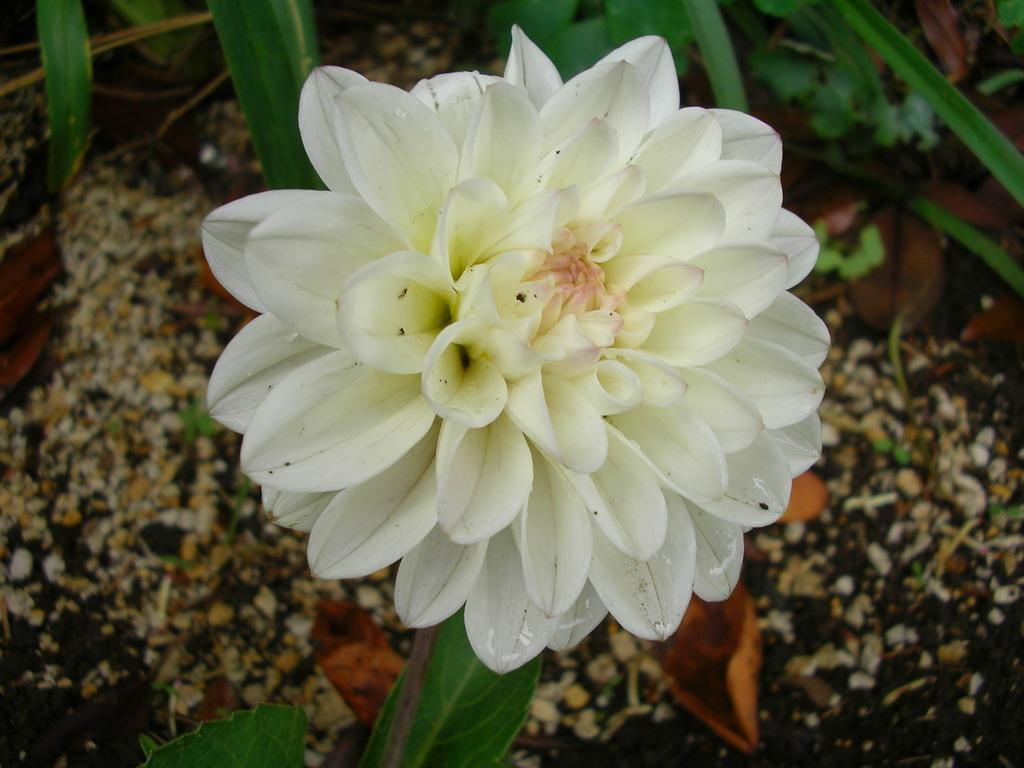What is the main subject of the image? The main subject of the image is a flower. What color is the flower? The flower is white in color. Where is the flower located in the image? The flower is in the middle of the image. What type of book is the flower reading in the image? There is no book present in the image, as it is a zoomed-in picture of a flower. 